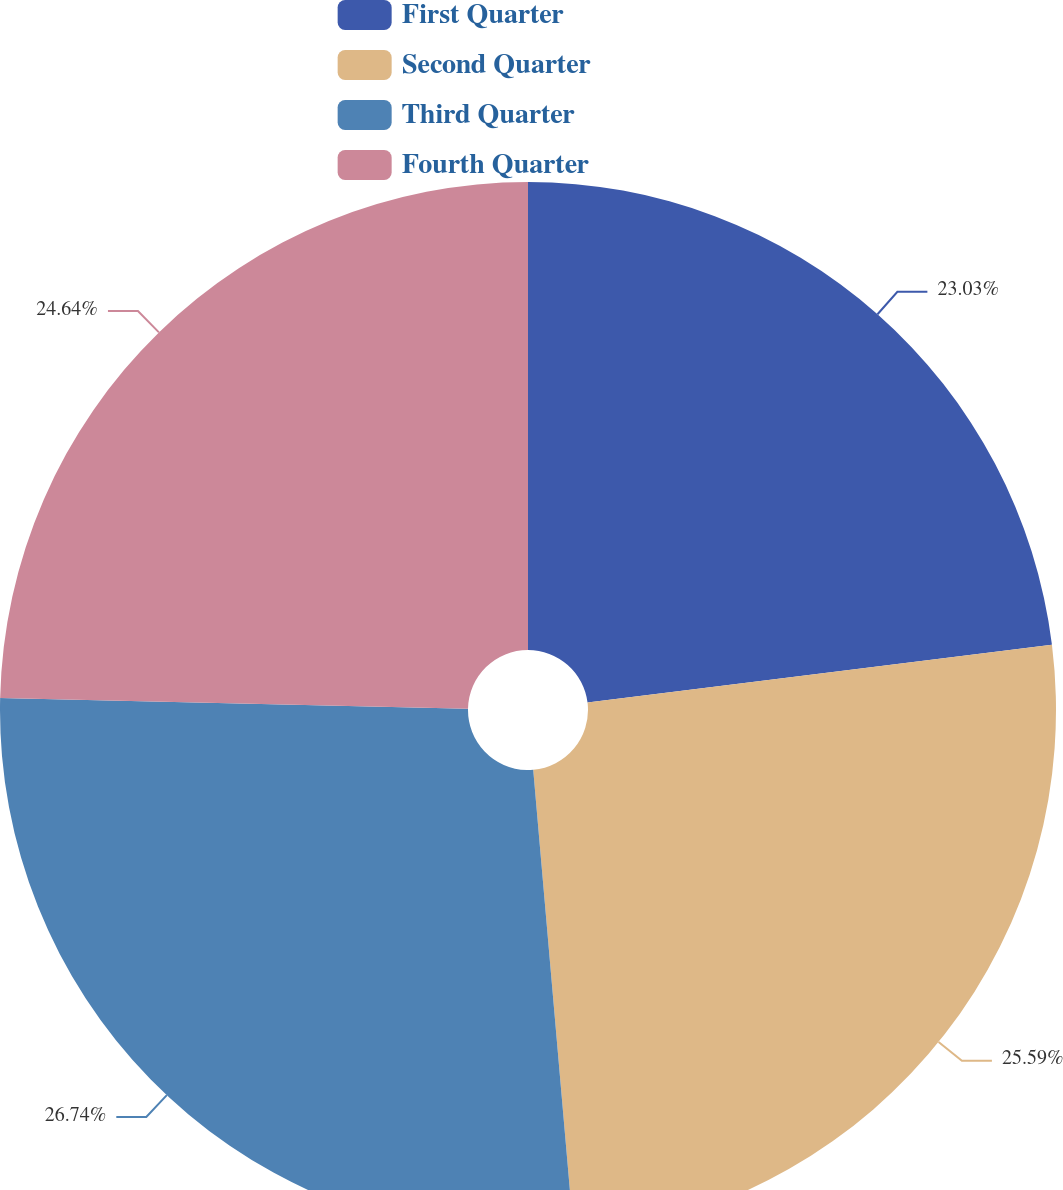Convert chart. <chart><loc_0><loc_0><loc_500><loc_500><pie_chart><fcel>First Quarter<fcel>Second Quarter<fcel>Third Quarter<fcel>Fourth Quarter<nl><fcel>23.03%<fcel>25.59%<fcel>26.75%<fcel>24.64%<nl></chart> 